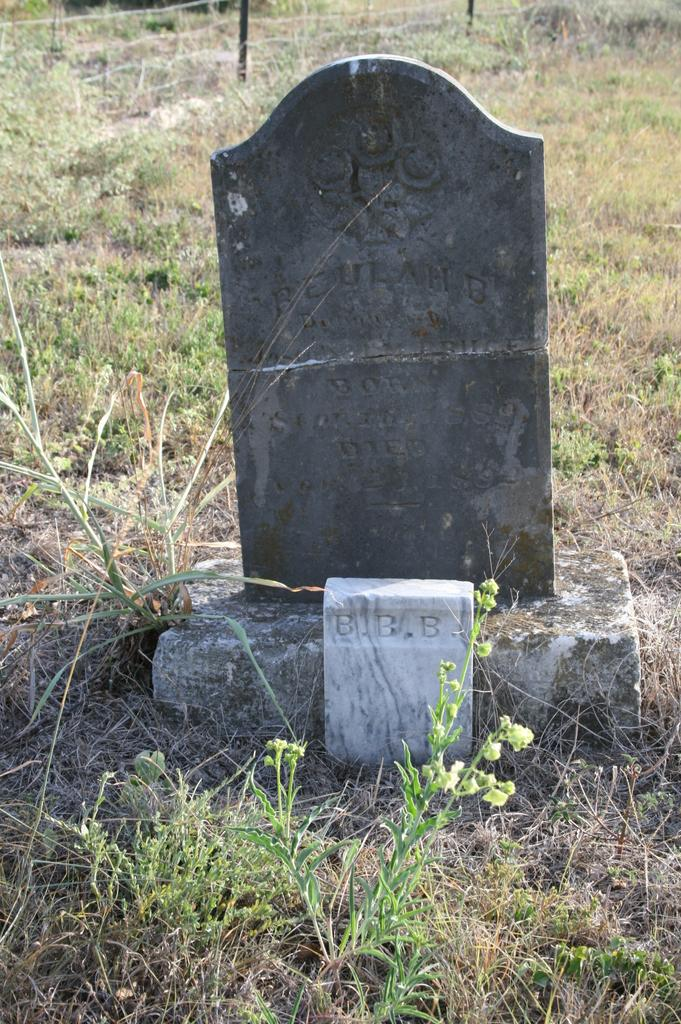What is the main object in the image? There is a headstone in the image. What type of vegetation is visible behind the headstone? There is grass behind the headstone. What is located behind the grass in the image? There is fencing behind the headstone. What type of quartz can be seen on the headstone in the image? There is no quartz present on the headstone in the image. Can you see a hose being used in the image? There is no hose visible in the image. 